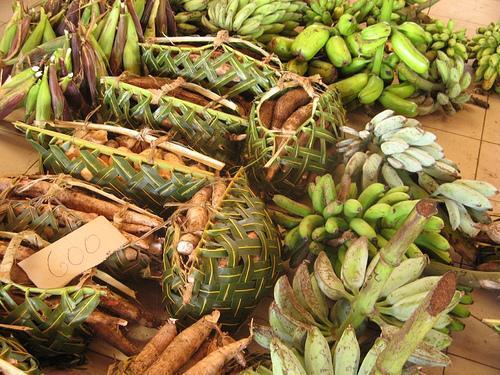How many baskets made from leaves are in the image?
Give a very brief answer. 7. 